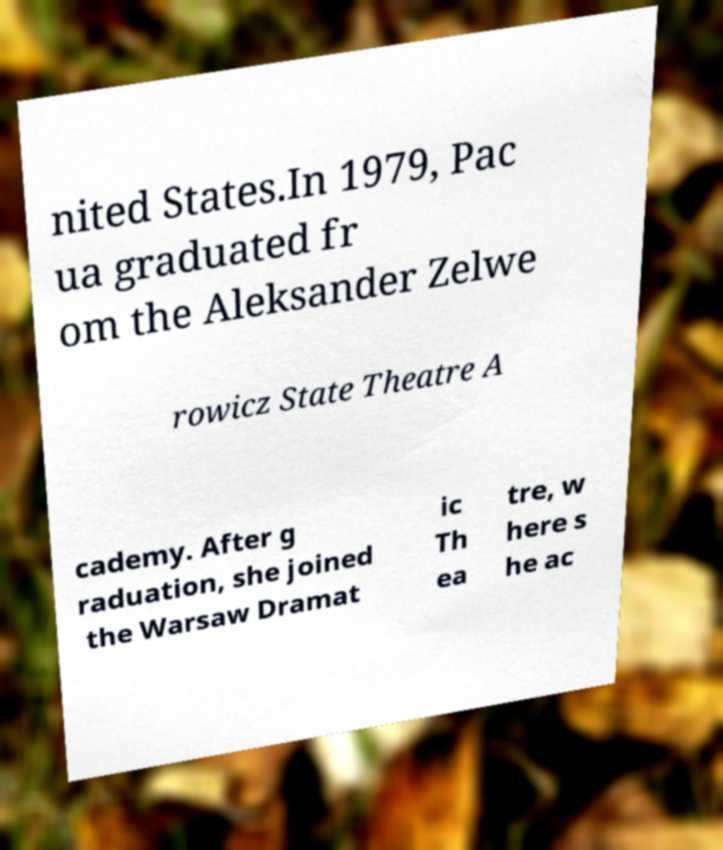Please read and relay the text visible in this image. What does it say? nited States.In 1979, Pac ua graduated fr om the Aleksander Zelwe rowicz State Theatre A cademy. After g raduation, she joined the Warsaw Dramat ic Th ea tre, w here s he ac 